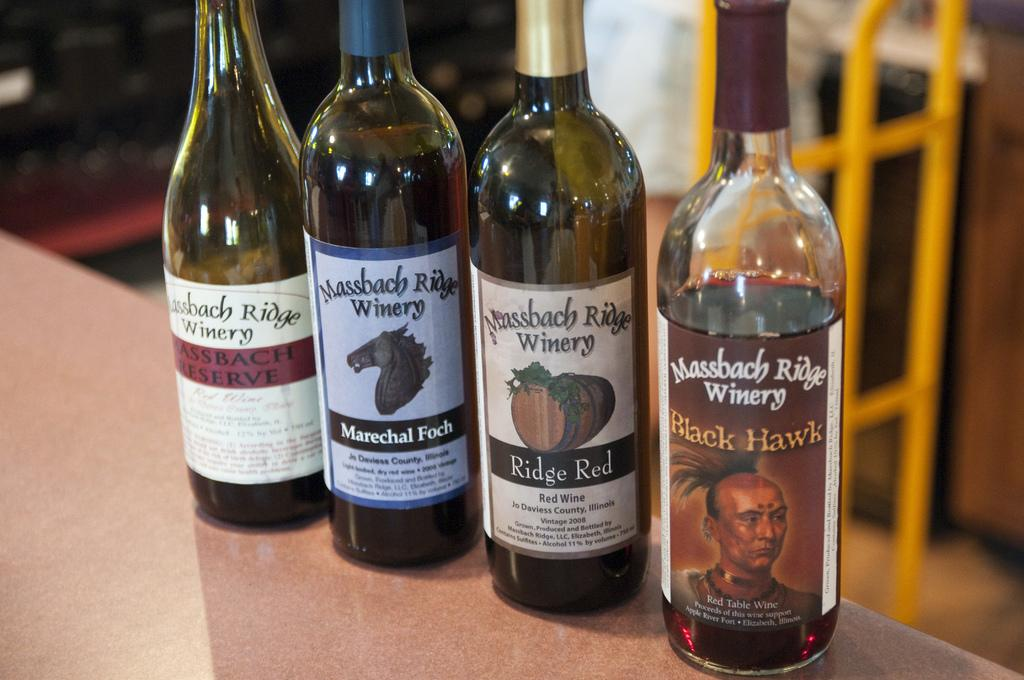How many wine bottles are on the table in the image? There are 4 wine bottles on the table in the image. Can you describe anything in the background of the image? Yes, there is a person and a fence in the background of the image. What type of horse can be seen in the image? There is no horse present in the image. What is the weather like in the image? The provided facts do not mention any information about the weather in the image. 